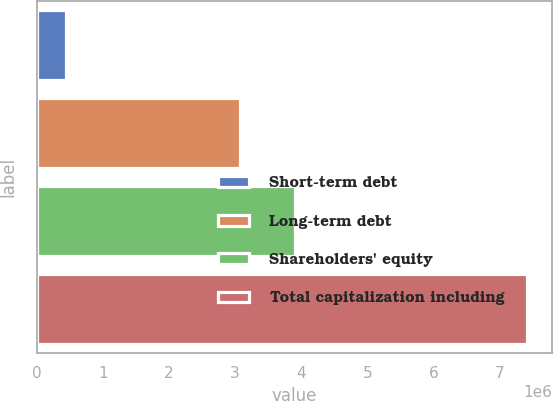Convert chart to OTSL. <chart><loc_0><loc_0><loc_500><loc_500><bar_chart><fcel>Short-term debt<fcel>Long-term debt<fcel>Shareholders' equity<fcel>Total capitalization including<nl><fcel>447745<fcel>3.06704e+06<fcel>3.89867e+06<fcel>7.41346e+06<nl></chart> 